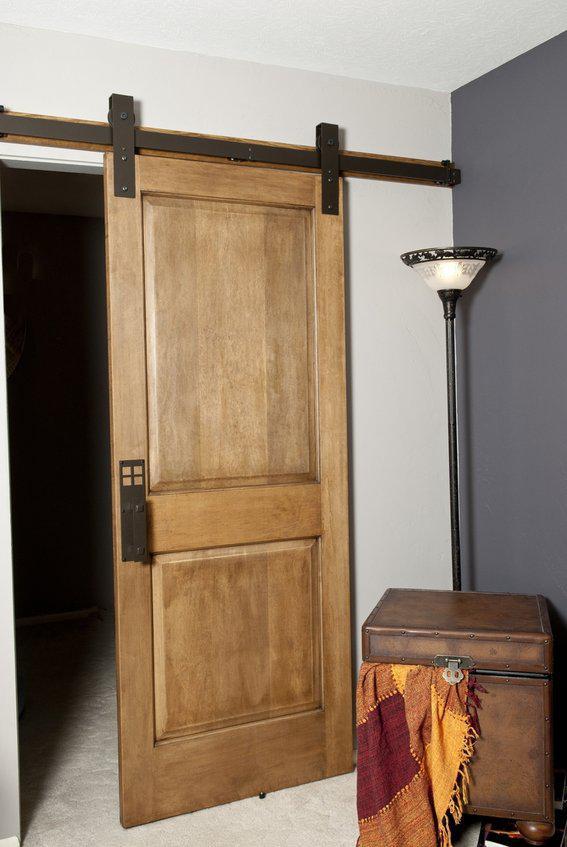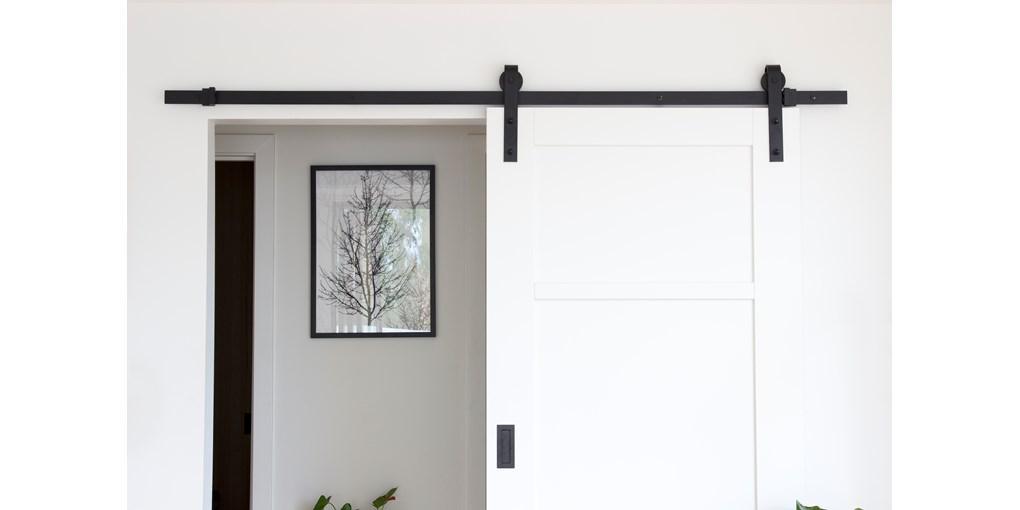The first image is the image on the left, the second image is the image on the right. Analyze the images presented: Is the assertion "There are three sliding doors." valid? Answer yes or no. No. 